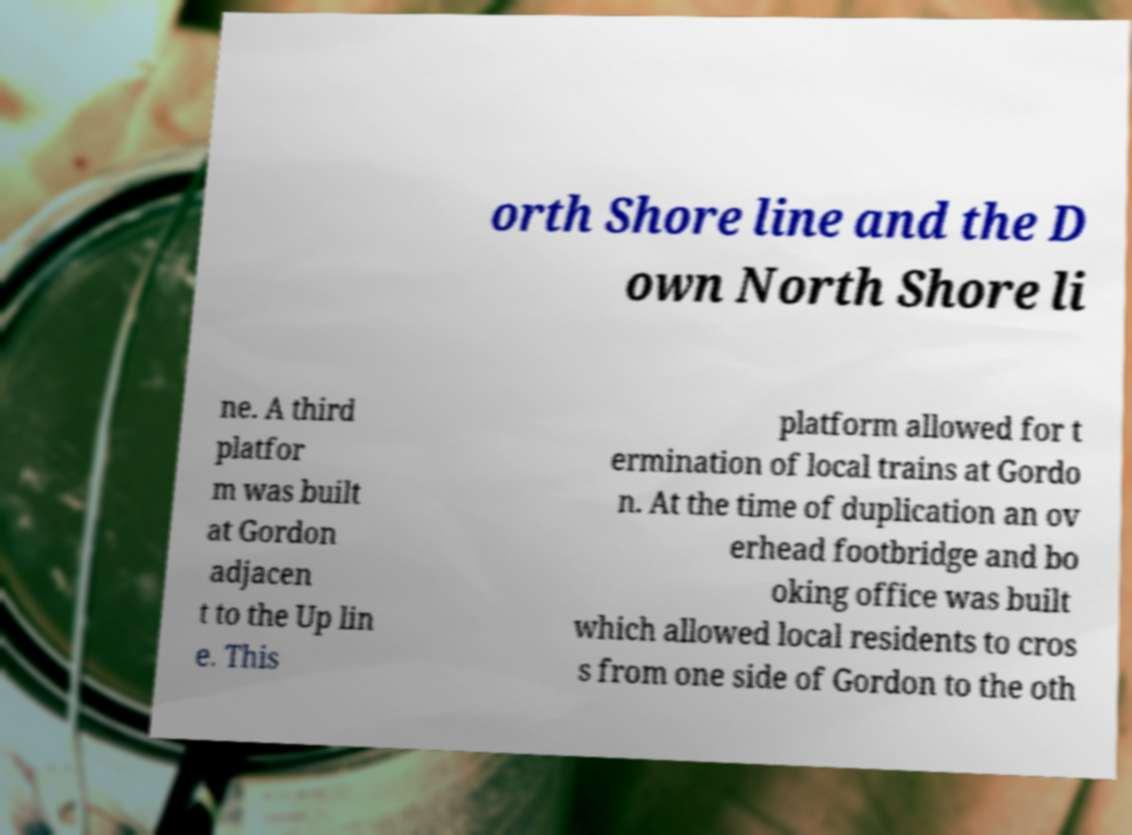There's text embedded in this image that I need extracted. Can you transcribe it verbatim? orth Shore line and the D own North Shore li ne. A third platfor m was built at Gordon adjacen t to the Up lin e. This platform allowed for t ermination of local trains at Gordo n. At the time of duplication an ov erhead footbridge and bo oking office was built which allowed local residents to cros s from one side of Gordon to the oth 